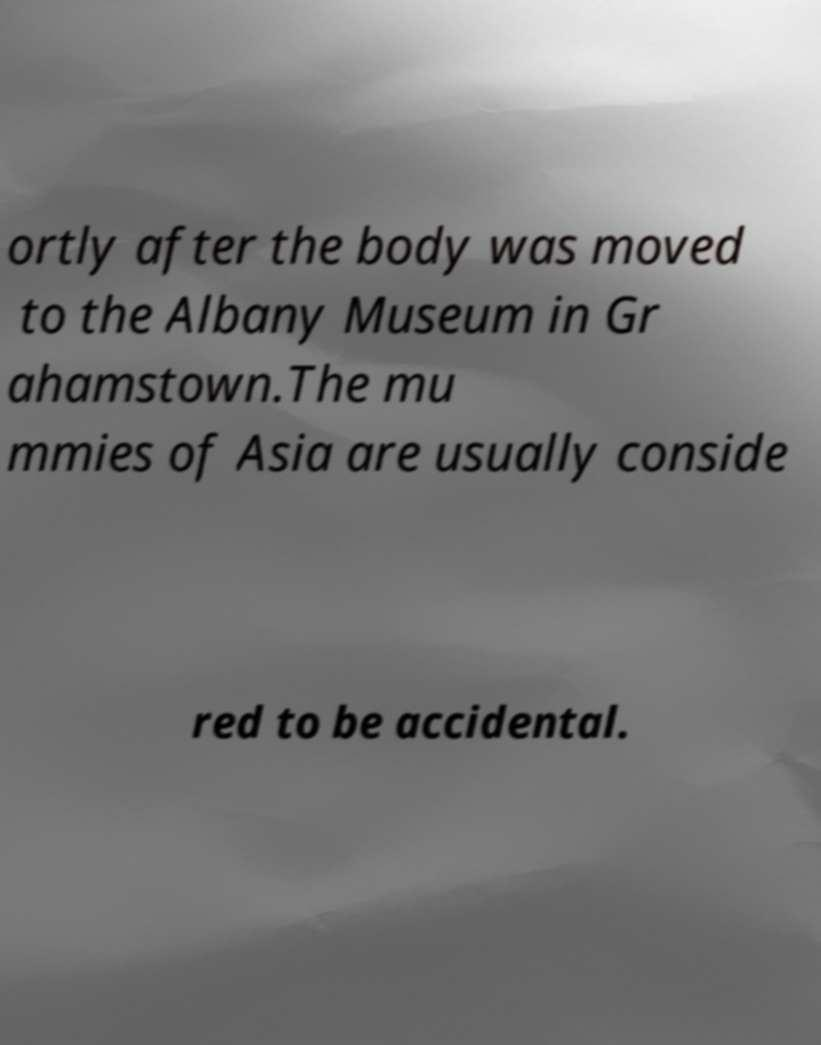Could you extract and type out the text from this image? ortly after the body was moved to the Albany Museum in Gr ahamstown.The mu mmies of Asia are usually conside red to be accidental. 